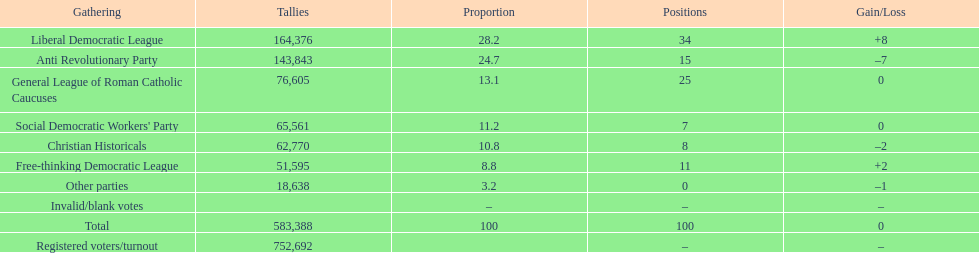Name the top three parties? Liberal Democratic League, Anti Revolutionary Party, General League of Roman Catholic Caucuses. 